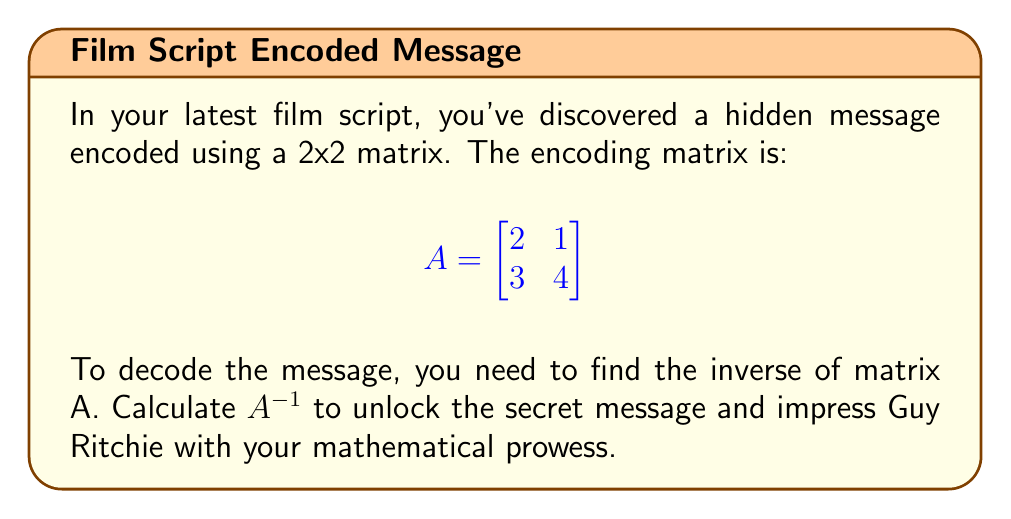Provide a solution to this math problem. To find the inverse of matrix A, we'll follow these steps:

1) First, calculate the determinant of A:
   $det(A) = (2 \times 4) - (1 \times 3) = 8 - 3 = 5$

2) The matrix is invertible since $det(A) \neq 0$.

3) Now, we'll find the adjugate matrix:
   $$adj(A) = \begin{bmatrix}
   4 & -1 \\
   -3 & 2
   \end{bmatrix}$$

4) The formula for the inverse is:
   $$A^{-1} = \frac{1}{det(A)} \times adj(A)$$

5) Substituting our values:
   $$A^{-1} = \frac{1}{5} \times \begin{bmatrix}
   4 & -1 \\
   -3 & 2
   \end{bmatrix}$$

6) Simplifying:
   $$A^{-1} = \begin{bmatrix}
   \frac{4}{5} & -\frac{1}{5} \\
   -\frac{3}{5} & \frac{2}{5}
   \end{bmatrix}$$

This is the inverse matrix that will decode the secret message in your script.
Answer: $$A^{-1} = \begin{bmatrix}
\frac{4}{5} & -\frac{1}{5} \\
-\frac{3}{5} & \frac{2}{5}
\end{bmatrix}$$ 